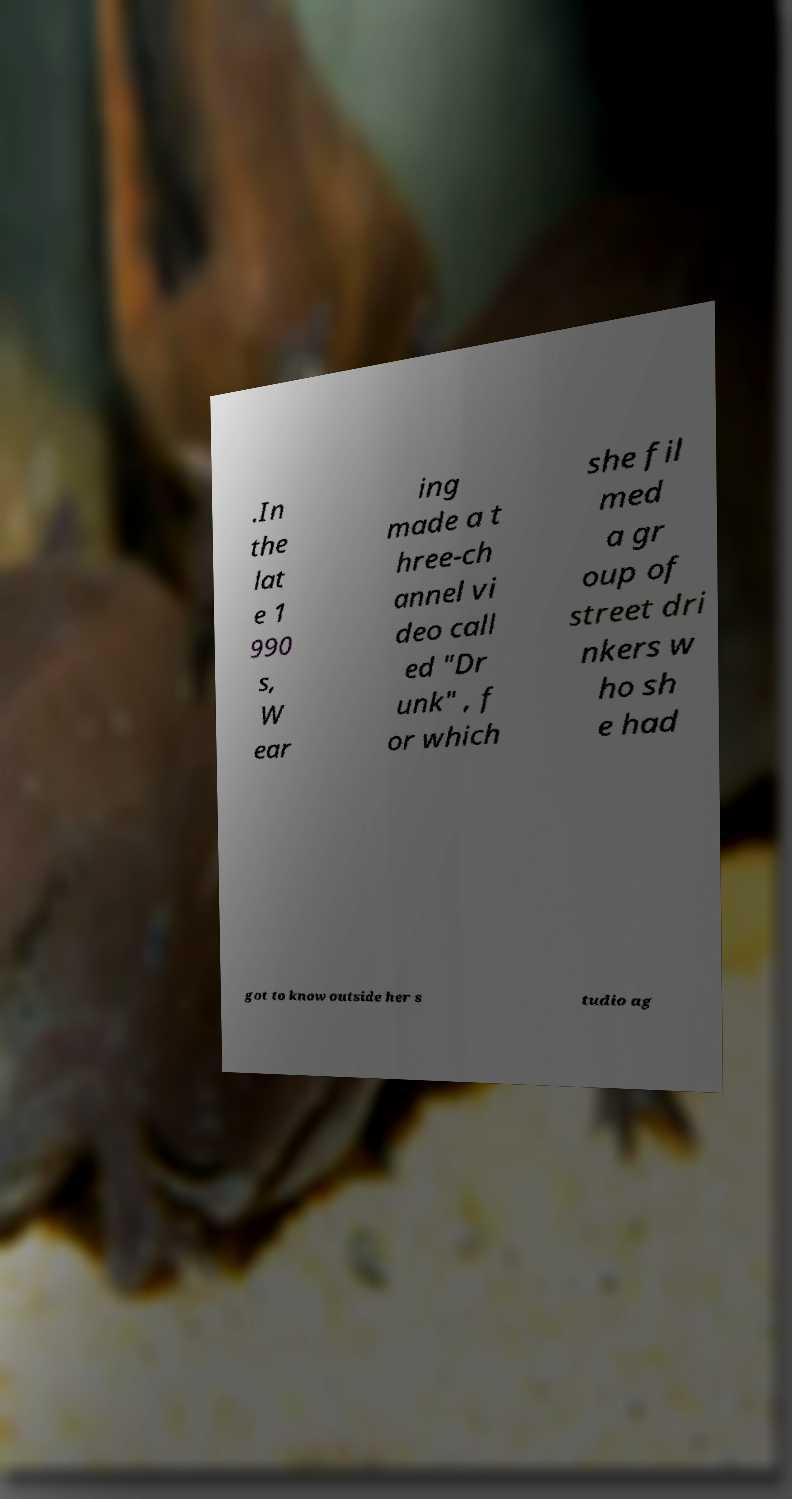Can you read and provide the text displayed in the image?This photo seems to have some interesting text. Can you extract and type it out for me? .In the lat e 1 990 s, W ear ing made a t hree-ch annel vi deo call ed "Dr unk" , f or which she fil med a gr oup of street dri nkers w ho sh e had got to know outside her s tudio ag 